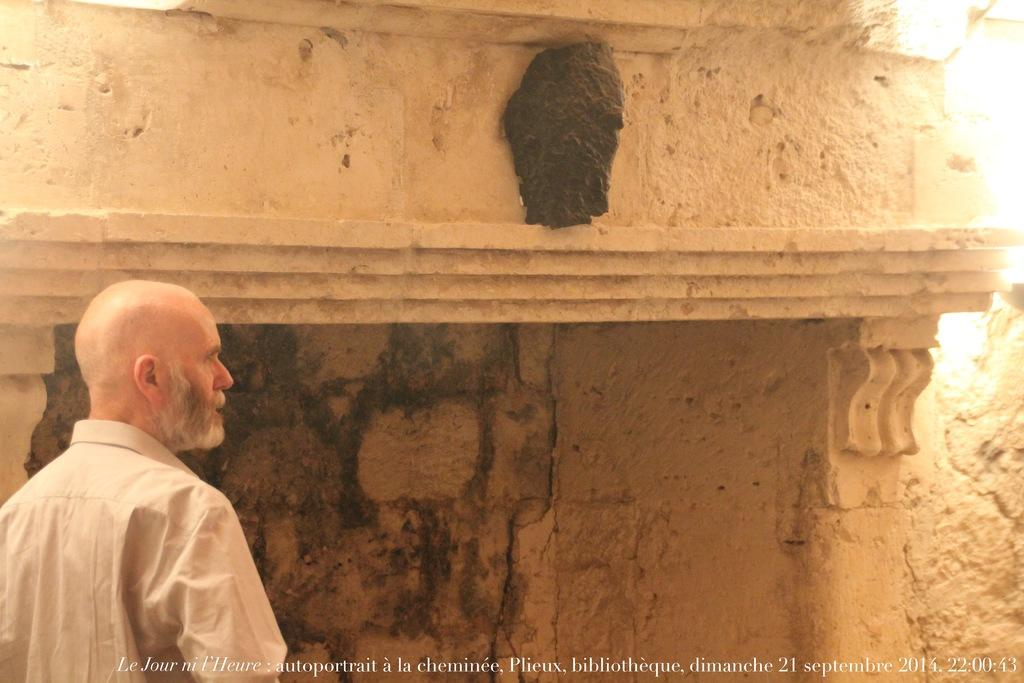Who or what is the main subject of the image? There is a person in the image. What is the person wearing? The person is wearing a white dress. What is the person's posture in the image? The person is standing. What can be seen in the background of the image? There is a wall in the background of the image. What type of bread can be seen in the image? There is no bread present in the image. How many pizzas are visible in the image? There are no pizzas present in the image. 